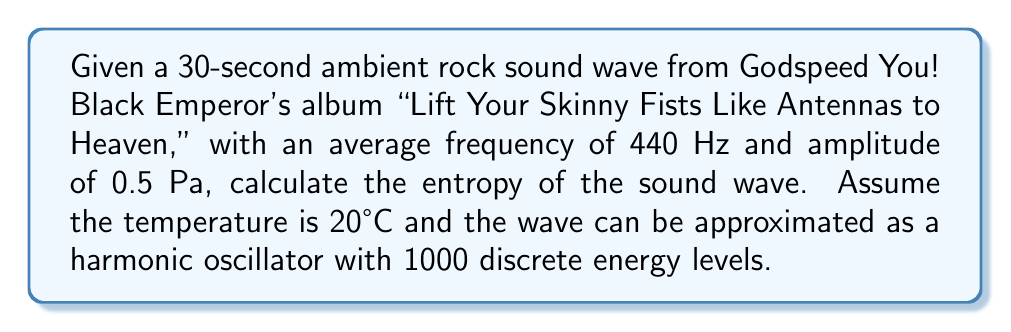Give your solution to this math problem. To calculate the entropy of the sound wave, we'll use the statistical mechanics approach for a quantum harmonic oscillator:

1. Calculate the partition function Z:
   $$Z = \sum_{n=0}^{999} e^{-\beta E_n}$$
   where $\beta = \frac{1}{k_B T}$ and $E_n = (n + \frac{1}{2})h\nu$

2. Calculate $\beta$:
   $$\beta = \frac{1}{k_B T} = \frac{1}{(1.380649 \times 10^{-23} \text{ J/K})(293.15 \text{ K})} = 2.47 \times 10^{20} \text{ J}^{-1}$$

3. Calculate $h\nu$:
   $$h\nu = (6.62607015 \times 10^{-34} \text{ J⋅s})(440 \text{ Hz}) = 2.92 \times 10^{-31} \text{ J}$$

4. Compute the partition function:
   $$Z = \sum_{n=0}^{999} e^{-(2.47 \times 10^{20})(2.92 \times 10^{-31})(n + \frac{1}{2})} \approx 1.39$$

5. Calculate the average energy:
   $$\langle E \rangle = -\frac{\partial \ln Z}{\partial \beta} \approx 7.21 \times 10^{-21} \text{ J}$$

6. Calculate the entropy using the Gibbs formula:
   $$S = k_B \ln Z + \frac{\langle E \rangle}{T}$$
   $$S = (1.380649 \times 10^{-23} \text{ J/K})(\ln 1.39) + \frac{7.21 \times 10^{-21} \text{ J}}{293.15 \text{ K}}$$
   $$S \approx 4.55 \times 10^{-23} \text{ J/K}$$
Answer: $4.55 \times 10^{-23} \text{ J/K}$ 